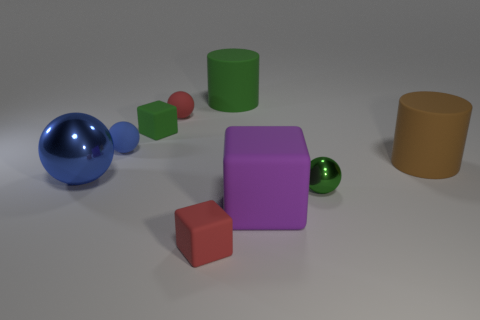Subtract 1 spheres. How many spheres are left? 3 Subtract all blocks. How many objects are left? 6 Subtract 0 blue cylinders. How many objects are left? 9 Subtract all small red matte blocks. Subtract all red rubber spheres. How many objects are left? 7 Add 3 big brown things. How many big brown things are left? 4 Add 2 green blocks. How many green blocks exist? 3 